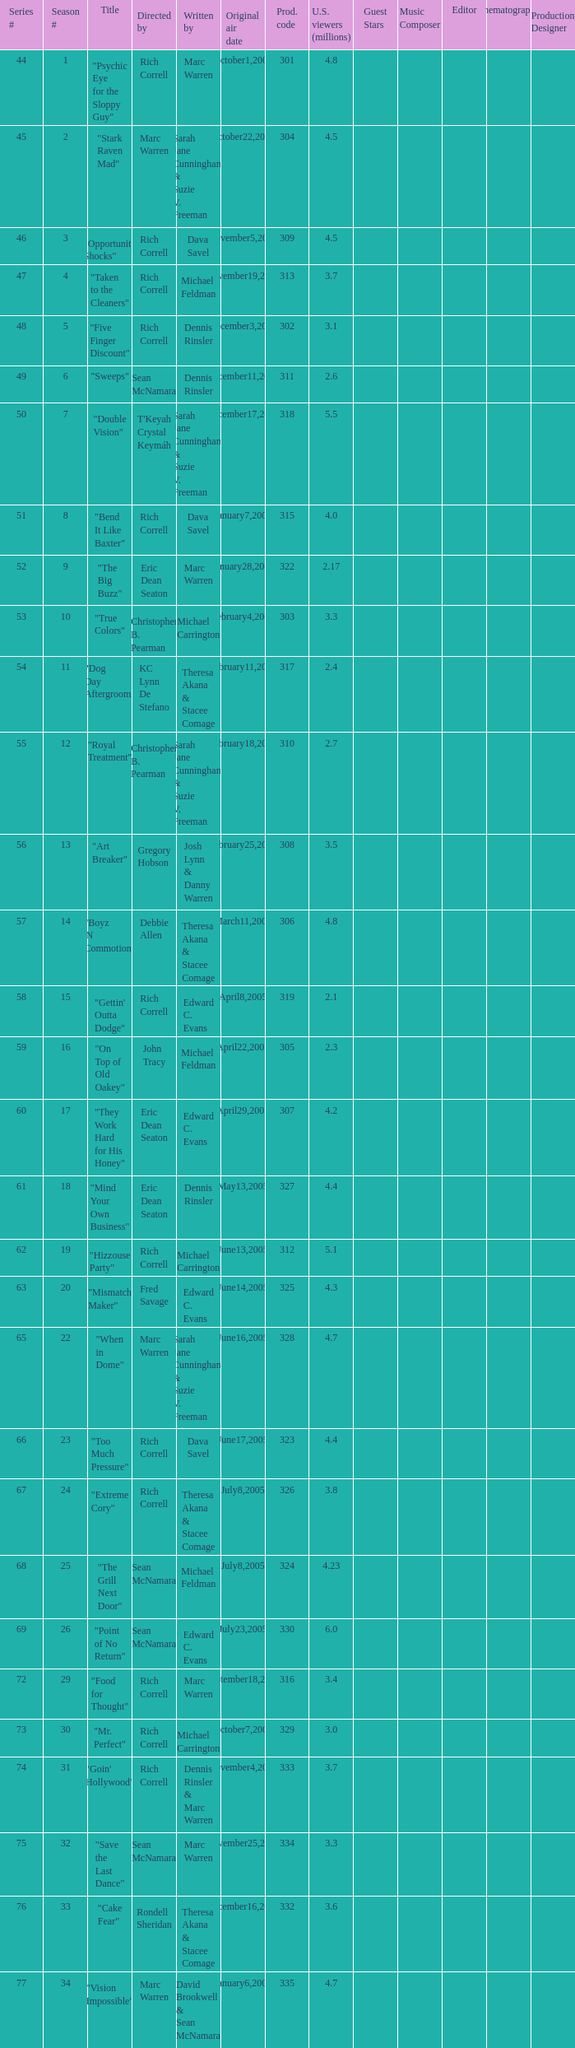What is the title of the episode directed by Rich Correll and written by Dennis Rinsler? "Five Finger Discount". 